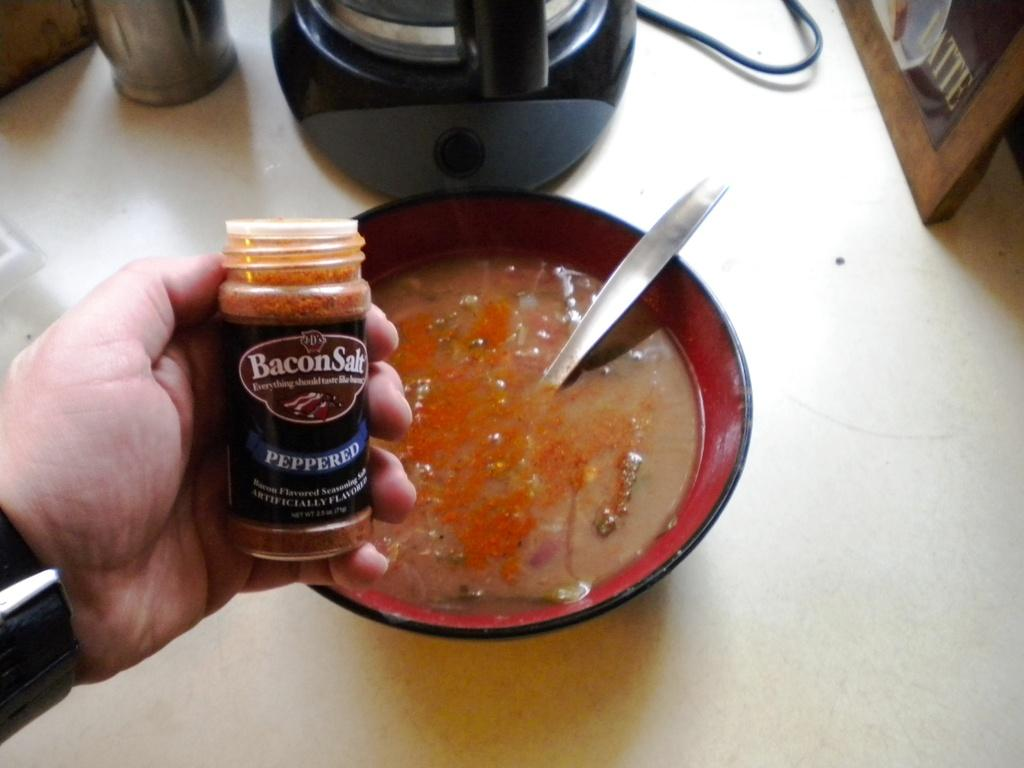What is in the cup that is visible in the image? There is soup in a cup in the image. What is the human hand doing in the image? The human hand is holding a pepper bottle in the image. Where is the cup placed in the image? The cup is placed on a table in the image. What type of dinosaurs can be seen roaming around the table in the image? There are no dinosaurs present in the image; it features a cup of soup, a human hand holding a pepper bottle, and a table. What kind of popcorn is being served for dinner in the image? There is no popcorn or dinner being served in the image; it only shows a cup of soup and a human hand holding a pepper bottle. 